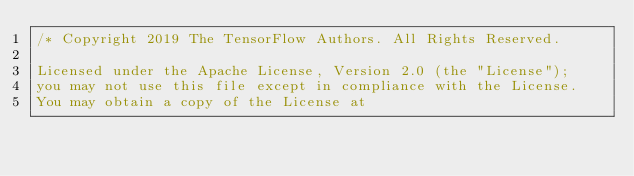<code> <loc_0><loc_0><loc_500><loc_500><_ObjectiveC_>/* Copyright 2019 The TensorFlow Authors. All Rights Reserved.

Licensed under the Apache License, Version 2.0 (the "License");
you may not use this file except in compliance with the License.
You may obtain a copy of the License at
</code> 